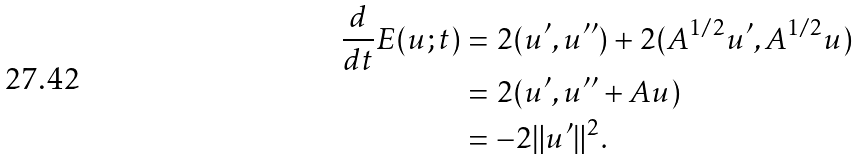<formula> <loc_0><loc_0><loc_500><loc_500>\frac { d } { d t } E ( u ; t ) & = 2 ( u ^ { \prime } , u ^ { \prime \prime } ) + 2 ( A ^ { 1 / 2 } u ^ { \prime } , A ^ { 1 / 2 } u ) \\ & = 2 ( u ^ { \prime } , u ^ { \prime \prime } + A u ) \\ & = - 2 \| u ^ { \prime } \| ^ { 2 } .</formula> 